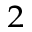Convert formula to latex. <formula><loc_0><loc_0><loc_500><loc_500>_ { 2 }</formula> 